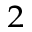Convert formula to latex. <formula><loc_0><loc_0><loc_500><loc_500>_ { 2 }</formula> 